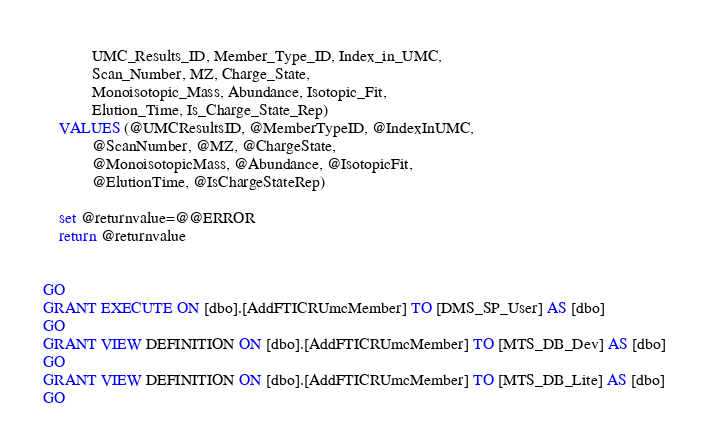<code> <loc_0><loc_0><loc_500><loc_500><_SQL_>			UMC_Results_ID, Member_Type_ID, Index_in_UMC,
			Scan_Number, MZ, Charge_State,
			Monoisotopic_Mass, Abundance, Isotopic_Fit, 
			Elution_Time, Is_Charge_State_Rep)
	VALUES (@UMCResultsID, @MemberTypeID, @IndexInUMC,
			@ScanNumber, @MZ, @ChargeState,
			@MonoisotopicMass, @Abundance, @IsotopicFit, 
			@ElutionTime, @IsChargeStateRep)

	set @returnvalue=@@ERROR
	return @returnvalue


GO
GRANT EXECUTE ON [dbo].[AddFTICRUmcMember] TO [DMS_SP_User] AS [dbo]
GO
GRANT VIEW DEFINITION ON [dbo].[AddFTICRUmcMember] TO [MTS_DB_Dev] AS [dbo]
GO
GRANT VIEW DEFINITION ON [dbo].[AddFTICRUmcMember] TO [MTS_DB_Lite] AS [dbo]
GO
</code> 